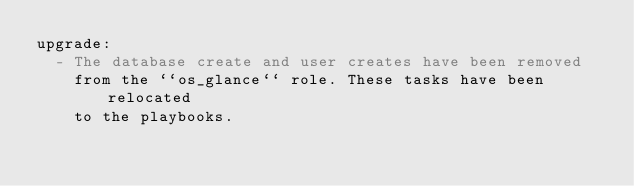Convert code to text. <code><loc_0><loc_0><loc_500><loc_500><_YAML_>upgrade:
  - The database create and user creates have been removed
    from the ``os_glance`` role. These tasks have been relocated
    to the playbooks.
</code> 